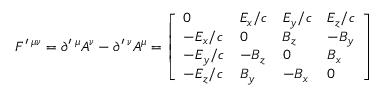<formula> <loc_0><loc_0><loc_500><loc_500>F ^ { \prime } \, ^ { \mu \nu } = \partial ^ { \prime } \, ^ { \mu } A ^ { \nu } - \partial ^ { \prime } \, ^ { \nu } A ^ { \mu } = { \left [ \begin{array} { l l l l } { 0 } & { E _ { x } / c } & { E _ { y } / c } & { E _ { z } / c } \\ { - E _ { x } / c } & { 0 } & { B _ { z } } & { - B _ { y } } \\ { - E _ { y } / c } & { - B _ { z } } & { 0 } & { B _ { x } } \\ { - E _ { z } / c } & { B _ { y } } & { - B _ { x } } & { 0 } \end{array} \right ] }</formula> 